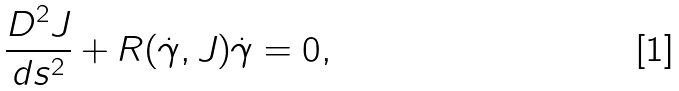Convert formula to latex. <formula><loc_0><loc_0><loc_500><loc_500>\frac { D ^ { 2 } J } { d s ^ { 2 } } + R ( \dot { \gamma } , J ) \dot { \gamma } = 0 ,</formula> 